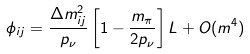Convert formula to latex. <formula><loc_0><loc_0><loc_500><loc_500>\phi _ { i j } = \frac { \Delta m ^ { 2 } _ { i j } } { p _ { \nu } } \left [ 1 - \frac { m _ { \pi } } { 2 p _ { \nu } } \right ] L + O ( m ^ { 4 } )</formula> 